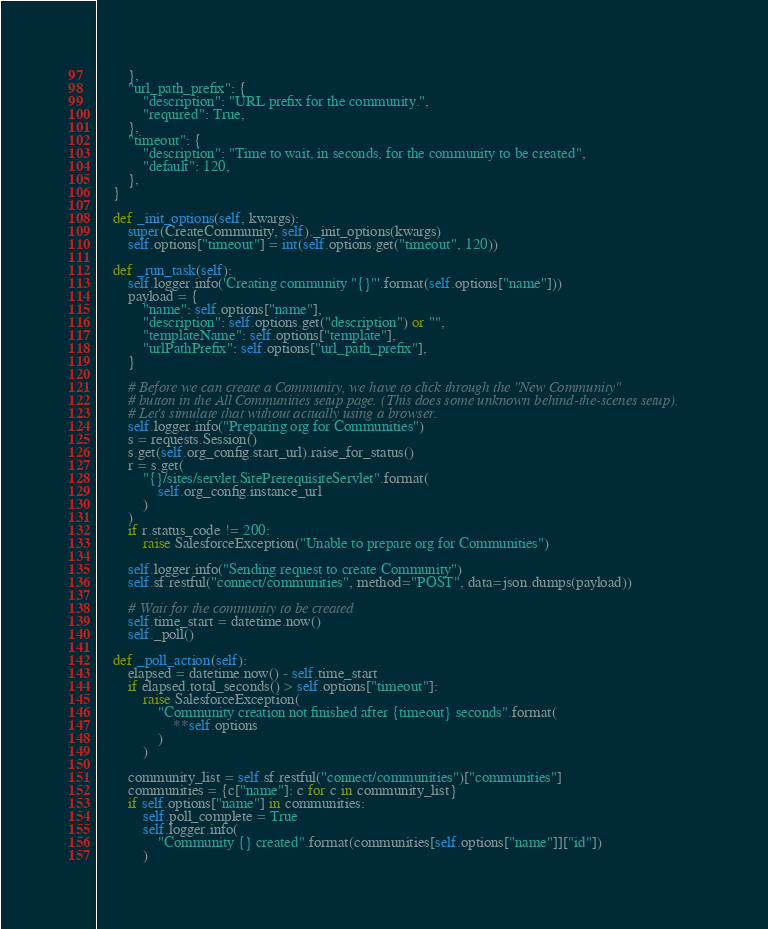Convert code to text. <code><loc_0><loc_0><loc_500><loc_500><_Python_>        },
        "url_path_prefix": {
            "description": "URL prefix for the community.",
            "required": True,
        },
        "timeout": {
            "description": "Time to wait, in seconds, for the community to be created",
            "default": 120,
        },
    }

    def _init_options(self, kwargs):
        super(CreateCommunity, self)._init_options(kwargs)
        self.options["timeout"] = int(self.options.get("timeout", 120))

    def _run_task(self):
        self.logger.info('Creating community "{}"'.format(self.options["name"]))
        payload = {
            "name": self.options["name"],
            "description": self.options.get("description") or "",
            "templateName": self.options["template"],
            "urlPathPrefix": self.options["url_path_prefix"],
        }

        # Before we can create a Community, we have to click through the "New Community"
        # button in the All Communities setup page. (This does some unknown behind-the-scenes setup).
        # Let's simulate that without actually using a browser.
        self.logger.info("Preparing org for Communities")
        s = requests.Session()
        s.get(self.org_config.start_url).raise_for_status()
        r = s.get(
            "{}/sites/servlet.SitePrerequisiteServlet".format(
                self.org_config.instance_url
            )
        )
        if r.status_code != 200:
            raise SalesforceException("Unable to prepare org for Communities")

        self.logger.info("Sending request to create Community")
        self.sf.restful("connect/communities", method="POST", data=json.dumps(payload))

        # Wait for the community to be created
        self.time_start = datetime.now()
        self._poll()

    def _poll_action(self):
        elapsed = datetime.now() - self.time_start
        if elapsed.total_seconds() > self.options["timeout"]:
            raise SalesforceException(
                "Community creation not finished after {timeout} seconds".format(
                    **self.options
                )
            )

        community_list = self.sf.restful("connect/communities")["communities"]
        communities = {c["name"]: c for c in community_list}
        if self.options["name"] in communities:
            self.poll_complete = True
            self.logger.info(
                "Community {} created".format(communities[self.options["name"]]["id"])
            )
</code> 